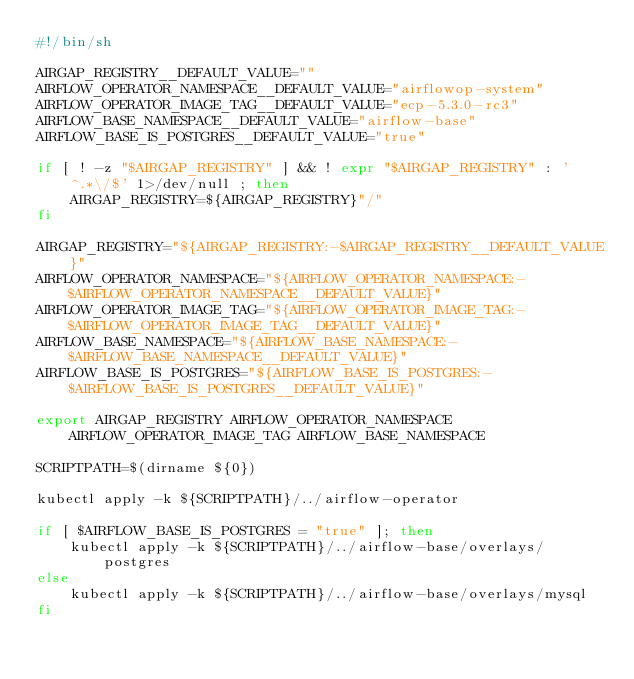<code> <loc_0><loc_0><loc_500><loc_500><_Bash_>#!/bin/sh

AIRGAP_REGISTRY__DEFAULT_VALUE=""
AIRFLOW_OPERATOR_NAMESPACE__DEFAULT_VALUE="airflowop-system"
AIRFLOW_OPERATOR_IMAGE_TAG__DEFAULT_VALUE="ecp-5.3.0-rc3"
AIRFLOW_BASE_NAMESPACE__DEFAULT_VALUE="airflow-base"
AIRFLOW_BASE_IS_POSTGRES__DEFAULT_VALUE="true"

if [ ! -z "$AIRGAP_REGISTRY" ] && ! expr "$AIRGAP_REGISTRY" : '^.*\/$' 1>/dev/null ; then
    AIRGAP_REGISTRY=${AIRGAP_REGISTRY}"/"
fi

AIRGAP_REGISTRY="${AIRGAP_REGISTRY:-$AIRGAP_REGISTRY__DEFAULT_VALUE}"
AIRFLOW_OPERATOR_NAMESPACE="${AIRFLOW_OPERATOR_NAMESPACE:-$AIRFLOW_OPERATOR_NAMESPACE__DEFAULT_VALUE}"
AIRFLOW_OPERATOR_IMAGE_TAG="${AIRFLOW_OPERATOR_IMAGE_TAG:-$AIRFLOW_OPERATOR_IMAGE_TAG__DEFAULT_VALUE}"
AIRFLOW_BASE_NAMESPACE="${AIRFLOW_BASE_NAMESPACE:-$AIRFLOW_BASE_NAMESPACE__DEFAULT_VALUE}"
AIRFLOW_BASE_IS_POSTGRES="${AIRFLOW_BASE_IS_POSTGRES:-$AIRFLOW_BASE_IS_POSTGRES__DEFAULT_VALUE}"

export AIRGAP_REGISTRY AIRFLOW_OPERATOR_NAMESPACE AIRFLOW_OPERATOR_IMAGE_TAG AIRFLOW_BASE_NAMESPACE

SCRIPTPATH=$(dirname ${0})

kubectl apply -k ${SCRIPTPATH}/../airflow-operator

if [ $AIRFLOW_BASE_IS_POSTGRES = "true" ]; then 
    kubectl apply -k ${SCRIPTPATH}/../airflow-base/overlays/postgres
else
    kubectl apply -k ${SCRIPTPATH}/../airflow-base/overlays/mysql
fi
</code> 